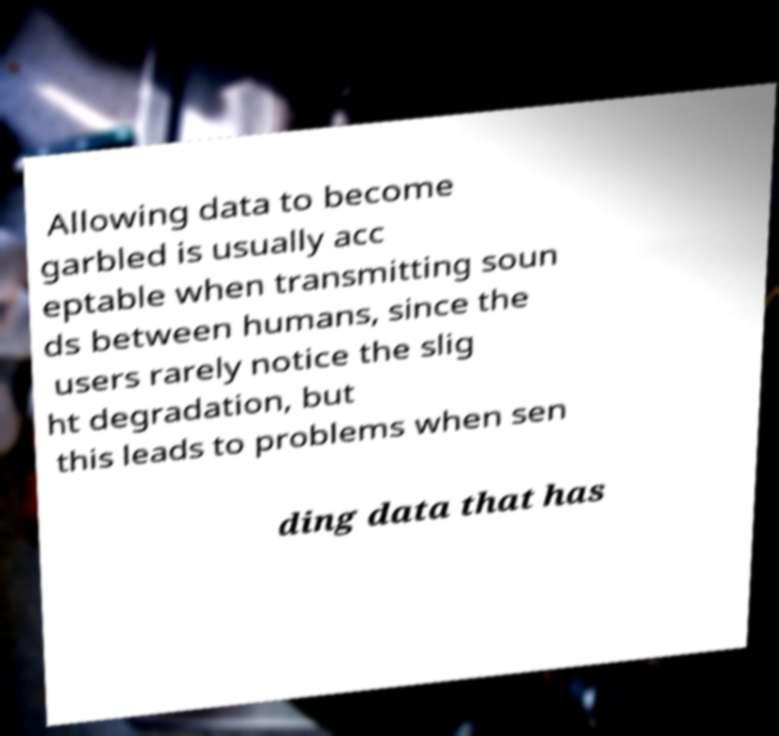Please read and relay the text visible in this image. What does it say? Allowing data to become garbled is usually acc eptable when transmitting soun ds between humans, since the users rarely notice the slig ht degradation, but this leads to problems when sen ding data that has 